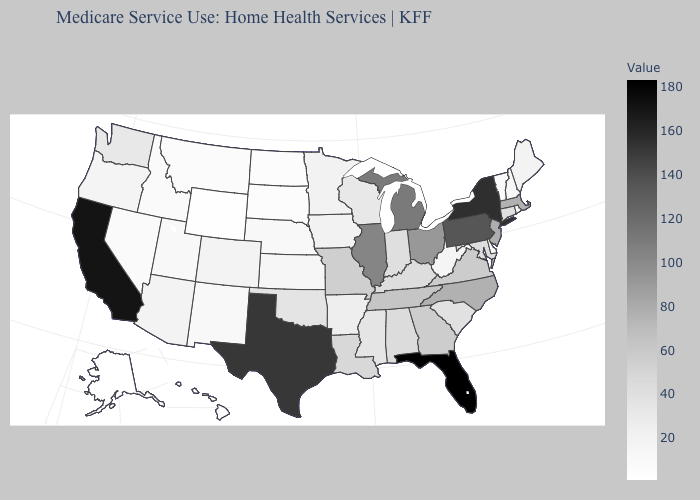Among the states that border Utah , does Wyoming have the lowest value?
Give a very brief answer. Yes. Among the states that border Massachusetts , does Vermont have the highest value?
Write a very short answer. No. Does Alaska have the lowest value in the USA?
Write a very short answer. Yes. Does Illinois have the highest value in the MidWest?
Short answer required. No. Does Tennessee have a lower value than New York?
Be succinct. Yes. Does the map have missing data?
Keep it brief. No. Among the states that border Missouri , does Nebraska have the lowest value?
Be succinct. Yes. 